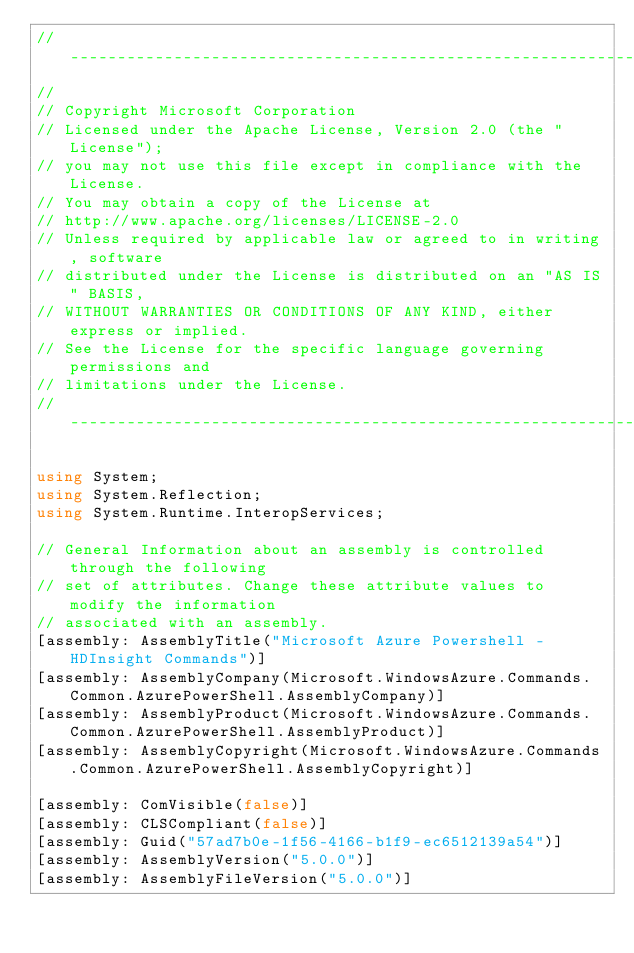Convert code to text. <code><loc_0><loc_0><loc_500><loc_500><_C#_>// ----------------------------------------------------------------------------------
//
// Copyright Microsoft Corporation
// Licensed under the Apache License, Version 2.0 (the "License");
// you may not use this file except in compliance with the License.
// You may obtain a copy of the License at
// http://www.apache.org/licenses/LICENSE-2.0
// Unless required by applicable law or agreed to in writing, software
// distributed under the License is distributed on an "AS IS" BASIS,
// WITHOUT WARRANTIES OR CONDITIONS OF ANY KIND, either express or implied.
// See the License for the specific language governing permissions and
// limitations under the License.
// ----------------------------------------------------------------------------------

using System;
using System.Reflection;
using System.Runtime.InteropServices;

// General Information about an assembly is controlled through the following 
// set of attributes. Change these attribute values to modify the information
// associated with an assembly.
[assembly: AssemblyTitle("Microsoft Azure Powershell - HDInsight Commands")]
[assembly: AssemblyCompany(Microsoft.WindowsAzure.Commands.Common.AzurePowerShell.AssemblyCompany)]
[assembly: AssemblyProduct(Microsoft.WindowsAzure.Commands.Common.AzurePowerShell.AssemblyProduct)]
[assembly: AssemblyCopyright(Microsoft.WindowsAzure.Commands.Common.AzurePowerShell.AssemblyCopyright)]

[assembly: ComVisible(false)]
[assembly: CLSCompliant(false)]
[assembly: Guid("57ad7b0e-1f56-4166-b1f9-ec6512139a54")]
[assembly: AssemblyVersion("5.0.0")]
[assembly: AssemblyFileVersion("5.0.0")]
</code> 